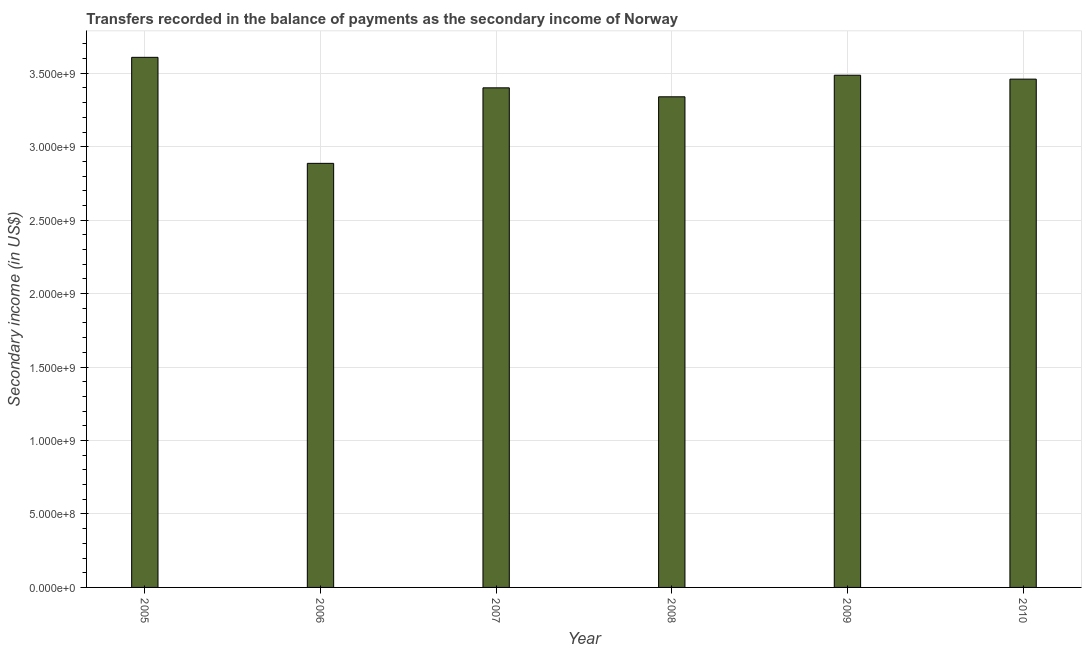Does the graph contain any zero values?
Keep it short and to the point. No. What is the title of the graph?
Ensure brevity in your answer.  Transfers recorded in the balance of payments as the secondary income of Norway. What is the label or title of the X-axis?
Give a very brief answer. Year. What is the label or title of the Y-axis?
Offer a very short reply. Secondary income (in US$). What is the amount of secondary income in 2006?
Offer a terse response. 2.89e+09. Across all years, what is the maximum amount of secondary income?
Your response must be concise. 3.61e+09. Across all years, what is the minimum amount of secondary income?
Keep it short and to the point. 2.89e+09. What is the sum of the amount of secondary income?
Your answer should be very brief. 2.02e+1. What is the difference between the amount of secondary income in 2005 and 2006?
Ensure brevity in your answer.  7.22e+08. What is the average amount of secondary income per year?
Keep it short and to the point. 3.36e+09. What is the median amount of secondary income?
Provide a short and direct response. 3.43e+09. In how many years, is the amount of secondary income greater than 2300000000 US$?
Your response must be concise. 6. What is the ratio of the amount of secondary income in 2006 to that in 2009?
Keep it short and to the point. 0.83. What is the difference between the highest and the second highest amount of secondary income?
Provide a succinct answer. 1.22e+08. Is the sum of the amount of secondary income in 2006 and 2009 greater than the maximum amount of secondary income across all years?
Keep it short and to the point. Yes. What is the difference between the highest and the lowest amount of secondary income?
Your response must be concise. 7.22e+08. Are all the bars in the graph horizontal?
Make the answer very short. No. How many years are there in the graph?
Keep it short and to the point. 6. What is the difference between two consecutive major ticks on the Y-axis?
Your answer should be very brief. 5.00e+08. What is the Secondary income (in US$) of 2005?
Give a very brief answer. 3.61e+09. What is the Secondary income (in US$) of 2006?
Your response must be concise. 2.89e+09. What is the Secondary income (in US$) in 2007?
Give a very brief answer. 3.40e+09. What is the Secondary income (in US$) in 2008?
Give a very brief answer. 3.34e+09. What is the Secondary income (in US$) of 2009?
Ensure brevity in your answer.  3.49e+09. What is the Secondary income (in US$) of 2010?
Provide a succinct answer. 3.46e+09. What is the difference between the Secondary income (in US$) in 2005 and 2006?
Ensure brevity in your answer.  7.22e+08. What is the difference between the Secondary income (in US$) in 2005 and 2007?
Give a very brief answer. 2.08e+08. What is the difference between the Secondary income (in US$) in 2005 and 2008?
Your answer should be compact. 2.69e+08. What is the difference between the Secondary income (in US$) in 2005 and 2009?
Your answer should be very brief. 1.22e+08. What is the difference between the Secondary income (in US$) in 2005 and 2010?
Keep it short and to the point. 1.48e+08. What is the difference between the Secondary income (in US$) in 2006 and 2007?
Keep it short and to the point. -5.14e+08. What is the difference between the Secondary income (in US$) in 2006 and 2008?
Your answer should be compact. -4.53e+08. What is the difference between the Secondary income (in US$) in 2006 and 2009?
Your answer should be very brief. -6.00e+08. What is the difference between the Secondary income (in US$) in 2006 and 2010?
Your answer should be compact. -5.73e+08. What is the difference between the Secondary income (in US$) in 2007 and 2008?
Provide a succinct answer. 6.10e+07. What is the difference between the Secondary income (in US$) in 2007 and 2009?
Your response must be concise. -8.59e+07. What is the difference between the Secondary income (in US$) in 2007 and 2010?
Your answer should be very brief. -5.92e+07. What is the difference between the Secondary income (in US$) in 2008 and 2009?
Make the answer very short. -1.47e+08. What is the difference between the Secondary income (in US$) in 2008 and 2010?
Your answer should be very brief. -1.20e+08. What is the difference between the Secondary income (in US$) in 2009 and 2010?
Ensure brevity in your answer.  2.66e+07. What is the ratio of the Secondary income (in US$) in 2005 to that in 2007?
Keep it short and to the point. 1.06. What is the ratio of the Secondary income (in US$) in 2005 to that in 2008?
Provide a short and direct response. 1.08. What is the ratio of the Secondary income (in US$) in 2005 to that in 2009?
Keep it short and to the point. 1.03. What is the ratio of the Secondary income (in US$) in 2005 to that in 2010?
Make the answer very short. 1.04. What is the ratio of the Secondary income (in US$) in 2006 to that in 2007?
Provide a succinct answer. 0.85. What is the ratio of the Secondary income (in US$) in 2006 to that in 2008?
Your answer should be very brief. 0.86. What is the ratio of the Secondary income (in US$) in 2006 to that in 2009?
Provide a succinct answer. 0.83. What is the ratio of the Secondary income (in US$) in 2006 to that in 2010?
Offer a very short reply. 0.83. What is the ratio of the Secondary income (in US$) in 2007 to that in 2010?
Your answer should be compact. 0.98. What is the ratio of the Secondary income (in US$) in 2008 to that in 2009?
Your answer should be compact. 0.96. 